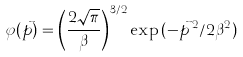Convert formula to latex. <formula><loc_0><loc_0><loc_500><loc_500>\varphi ( \vec { p } ) = \left ( \frac { 2 \sqrt { \pi } } { \beta } \right ) ^ { 3 / 2 } \exp { ( - \vec { p } \, ^ { 2 } / 2 \beta ^ { 2 } ) }</formula> 